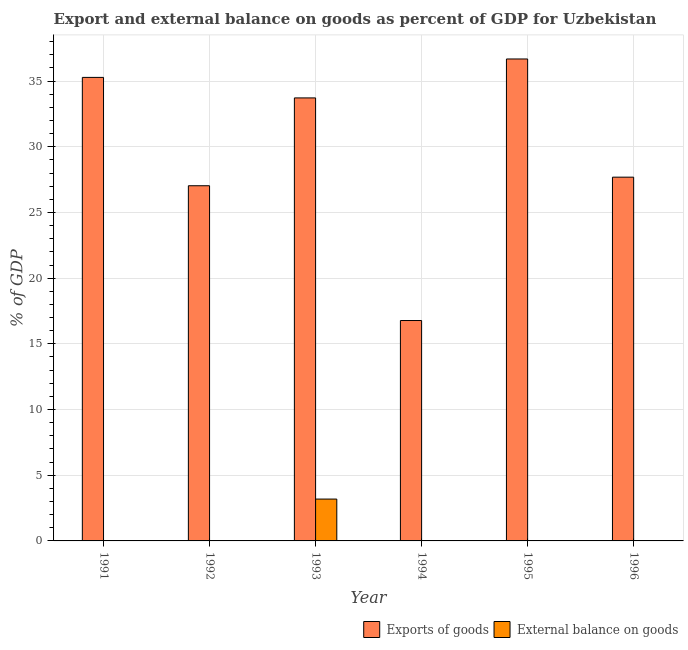How many different coloured bars are there?
Provide a short and direct response. 2. Are the number of bars per tick equal to the number of legend labels?
Offer a terse response. No. Across all years, what is the maximum external balance on goods as percentage of gdp?
Provide a short and direct response. 3.19. What is the total external balance on goods as percentage of gdp in the graph?
Keep it short and to the point. 3.19. What is the difference between the export of goods as percentage of gdp in 1991 and that in 1995?
Make the answer very short. -1.4. What is the average export of goods as percentage of gdp per year?
Provide a short and direct response. 29.53. In how many years, is the external balance on goods as percentage of gdp greater than 1 %?
Keep it short and to the point. 1. What is the ratio of the export of goods as percentage of gdp in 1994 to that in 1995?
Keep it short and to the point. 0.46. Is the export of goods as percentage of gdp in 1994 less than that in 1996?
Your response must be concise. Yes. What is the difference between the highest and the second highest export of goods as percentage of gdp?
Offer a very short reply. 1.4. What is the difference between the highest and the lowest export of goods as percentage of gdp?
Give a very brief answer. 19.91. In how many years, is the export of goods as percentage of gdp greater than the average export of goods as percentage of gdp taken over all years?
Offer a terse response. 3. Is the sum of the export of goods as percentage of gdp in 1991 and 1993 greater than the maximum external balance on goods as percentage of gdp across all years?
Offer a very short reply. Yes. How many bars are there?
Provide a succinct answer. 7. How many years are there in the graph?
Your answer should be compact. 6. Are the values on the major ticks of Y-axis written in scientific E-notation?
Make the answer very short. No. Where does the legend appear in the graph?
Your answer should be very brief. Bottom right. What is the title of the graph?
Offer a terse response. Export and external balance on goods as percent of GDP for Uzbekistan. What is the label or title of the X-axis?
Offer a very short reply. Year. What is the label or title of the Y-axis?
Give a very brief answer. % of GDP. What is the % of GDP in Exports of goods in 1991?
Give a very brief answer. 35.28. What is the % of GDP of External balance on goods in 1991?
Give a very brief answer. 0. What is the % of GDP in Exports of goods in 1992?
Your answer should be compact. 27.03. What is the % of GDP in External balance on goods in 1992?
Offer a terse response. 0. What is the % of GDP in Exports of goods in 1993?
Offer a very short reply. 33.72. What is the % of GDP in External balance on goods in 1993?
Ensure brevity in your answer.  3.19. What is the % of GDP in Exports of goods in 1994?
Make the answer very short. 16.78. What is the % of GDP of External balance on goods in 1994?
Your answer should be compact. 0. What is the % of GDP in Exports of goods in 1995?
Offer a terse response. 36.68. What is the % of GDP in External balance on goods in 1995?
Give a very brief answer. 0. What is the % of GDP in Exports of goods in 1996?
Your answer should be compact. 27.69. Across all years, what is the maximum % of GDP of Exports of goods?
Your answer should be compact. 36.68. Across all years, what is the maximum % of GDP of External balance on goods?
Your answer should be very brief. 3.19. Across all years, what is the minimum % of GDP of Exports of goods?
Provide a short and direct response. 16.78. What is the total % of GDP of Exports of goods in the graph?
Your answer should be very brief. 177.18. What is the total % of GDP in External balance on goods in the graph?
Your answer should be compact. 3.19. What is the difference between the % of GDP of Exports of goods in 1991 and that in 1992?
Your answer should be very brief. 8.25. What is the difference between the % of GDP in Exports of goods in 1991 and that in 1993?
Provide a short and direct response. 1.56. What is the difference between the % of GDP of Exports of goods in 1991 and that in 1994?
Your response must be concise. 18.5. What is the difference between the % of GDP of Exports of goods in 1991 and that in 1995?
Make the answer very short. -1.4. What is the difference between the % of GDP in Exports of goods in 1991 and that in 1996?
Offer a very short reply. 7.59. What is the difference between the % of GDP in Exports of goods in 1992 and that in 1993?
Provide a succinct answer. -6.69. What is the difference between the % of GDP in Exports of goods in 1992 and that in 1994?
Your response must be concise. 10.26. What is the difference between the % of GDP of Exports of goods in 1992 and that in 1995?
Your response must be concise. -9.65. What is the difference between the % of GDP of Exports of goods in 1992 and that in 1996?
Offer a very short reply. -0.65. What is the difference between the % of GDP of Exports of goods in 1993 and that in 1994?
Give a very brief answer. 16.94. What is the difference between the % of GDP in Exports of goods in 1993 and that in 1995?
Offer a terse response. -2.96. What is the difference between the % of GDP of Exports of goods in 1993 and that in 1996?
Offer a terse response. 6.03. What is the difference between the % of GDP of Exports of goods in 1994 and that in 1995?
Your answer should be very brief. -19.91. What is the difference between the % of GDP in Exports of goods in 1994 and that in 1996?
Offer a terse response. -10.91. What is the difference between the % of GDP in Exports of goods in 1995 and that in 1996?
Keep it short and to the point. 9. What is the difference between the % of GDP of Exports of goods in 1991 and the % of GDP of External balance on goods in 1993?
Offer a very short reply. 32.09. What is the difference between the % of GDP of Exports of goods in 1992 and the % of GDP of External balance on goods in 1993?
Your answer should be very brief. 23.85. What is the average % of GDP in Exports of goods per year?
Keep it short and to the point. 29.53. What is the average % of GDP of External balance on goods per year?
Make the answer very short. 0.53. In the year 1993, what is the difference between the % of GDP of Exports of goods and % of GDP of External balance on goods?
Provide a succinct answer. 30.53. What is the ratio of the % of GDP in Exports of goods in 1991 to that in 1992?
Make the answer very short. 1.3. What is the ratio of the % of GDP of Exports of goods in 1991 to that in 1993?
Offer a very short reply. 1.05. What is the ratio of the % of GDP of Exports of goods in 1991 to that in 1994?
Keep it short and to the point. 2.1. What is the ratio of the % of GDP of Exports of goods in 1991 to that in 1995?
Your answer should be compact. 0.96. What is the ratio of the % of GDP in Exports of goods in 1991 to that in 1996?
Keep it short and to the point. 1.27. What is the ratio of the % of GDP in Exports of goods in 1992 to that in 1993?
Your answer should be compact. 0.8. What is the ratio of the % of GDP of Exports of goods in 1992 to that in 1994?
Keep it short and to the point. 1.61. What is the ratio of the % of GDP in Exports of goods in 1992 to that in 1995?
Offer a terse response. 0.74. What is the ratio of the % of GDP of Exports of goods in 1992 to that in 1996?
Your response must be concise. 0.98. What is the ratio of the % of GDP of Exports of goods in 1993 to that in 1994?
Your response must be concise. 2.01. What is the ratio of the % of GDP of Exports of goods in 1993 to that in 1995?
Keep it short and to the point. 0.92. What is the ratio of the % of GDP of Exports of goods in 1993 to that in 1996?
Provide a short and direct response. 1.22. What is the ratio of the % of GDP of Exports of goods in 1994 to that in 1995?
Make the answer very short. 0.46. What is the ratio of the % of GDP in Exports of goods in 1994 to that in 1996?
Make the answer very short. 0.61. What is the ratio of the % of GDP of Exports of goods in 1995 to that in 1996?
Your response must be concise. 1.32. What is the difference between the highest and the second highest % of GDP in Exports of goods?
Your response must be concise. 1.4. What is the difference between the highest and the lowest % of GDP of Exports of goods?
Your answer should be compact. 19.91. What is the difference between the highest and the lowest % of GDP in External balance on goods?
Offer a terse response. 3.19. 